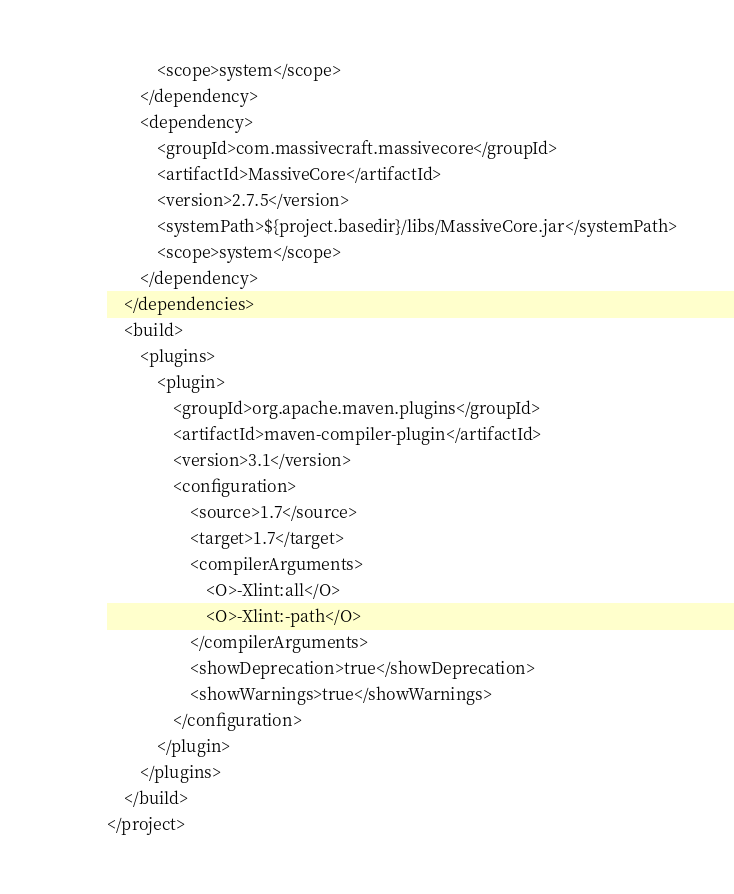Convert code to text. <code><loc_0><loc_0><loc_500><loc_500><_XML_>            <scope>system</scope>
        </dependency>
        <dependency>
            <groupId>com.massivecraft.massivecore</groupId>
            <artifactId>MassiveCore</artifactId>
            <version>2.7.5</version>
            <systemPath>${project.basedir}/libs/MassiveCore.jar</systemPath>
            <scope>system</scope>
        </dependency>
    </dependencies>
    <build>
        <plugins>
            <plugin>
                <groupId>org.apache.maven.plugins</groupId>
                <artifactId>maven-compiler-plugin</artifactId>
                <version>3.1</version>
                <configuration>
                    <source>1.7</source>
                    <target>1.7</target>
                    <compilerArguments>
                        <O>-Xlint:all</O>
                        <O>-Xlint:-path</O>
                    </compilerArguments>
                    <showDeprecation>true</showDeprecation>
                    <showWarnings>true</showWarnings>
                </configuration>
            </plugin>
        </plugins>
    </build>
</project></code> 